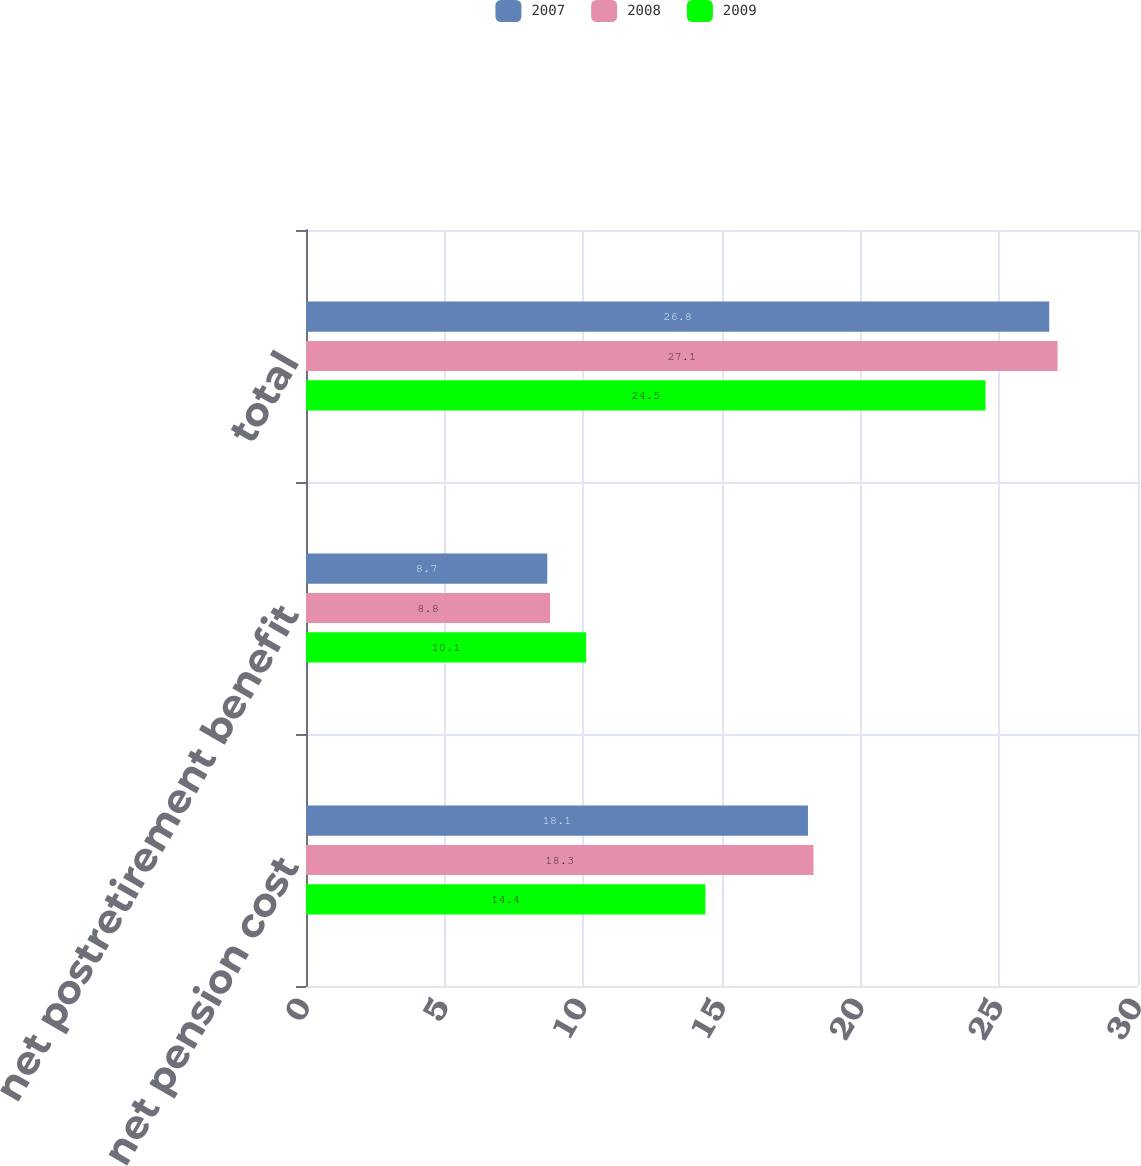Convert chart to OTSL. <chart><loc_0><loc_0><loc_500><loc_500><stacked_bar_chart><ecel><fcel>net pension cost<fcel>net postretirement benefit<fcel>total<nl><fcel>2007<fcel>18.1<fcel>8.7<fcel>26.8<nl><fcel>2008<fcel>18.3<fcel>8.8<fcel>27.1<nl><fcel>2009<fcel>14.4<fcel>10.1<fcel>24.5<nl></chart> 